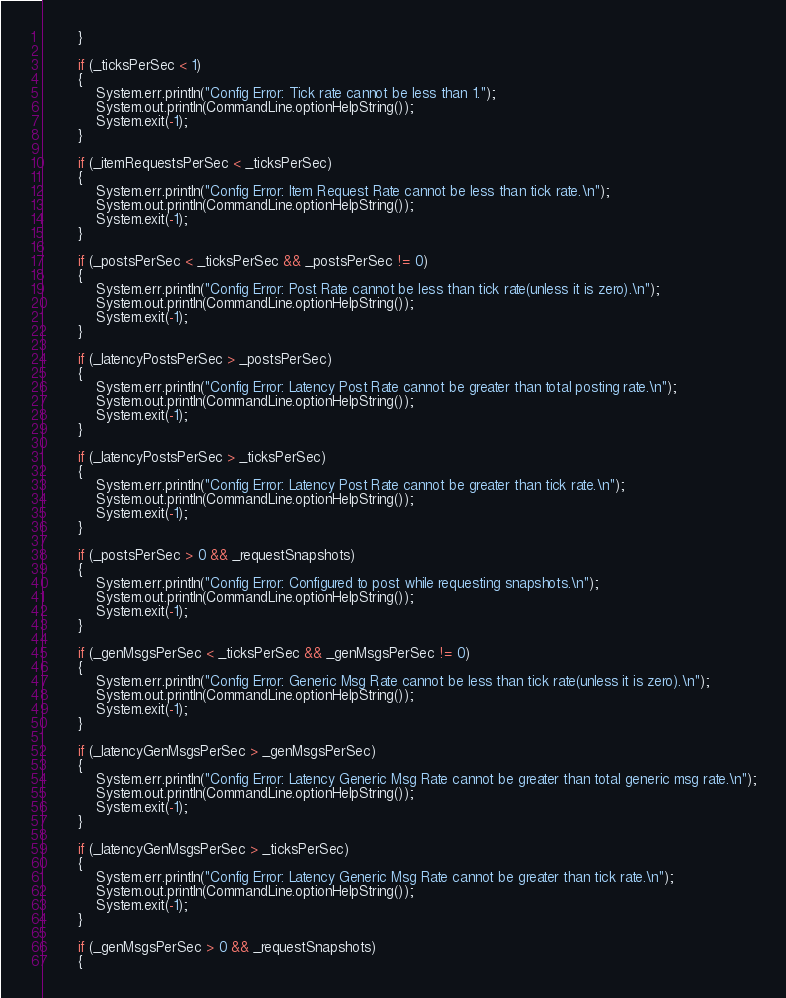<code> <loc_0><loc_0><loc_500><loc_500><_Java_>        }

        if (_ticksPerSec < 1)
        {
            System.err.println("Config Error: Tick rate cannot be less than 1.");
            System.out.println(CommandLine.optionHelpString());
            System.exit(-1);
        } 
        
		if (_itemRequestsPerSec < _ticksPerSec)
		{
			System.err.println("Config Error: Item Request Rate cannot be less than tick rate.\n");
			System.out.println(CommandLine.optionHelpString());
			System.exit(-1);
		}

		if (_postsPerSec < _ticksPerSec && _postsPerSec != 0)
		{
			System.err.println("Config Error: Post Rate cannot be less than tick rate(unless it is zero).\n");
			System.out.println(CommandLine.optionHelpString());
			System.exit(-1);
		}

		if (_latencyPostsPerSec > _postsPerSec)
		{
			System.err.println("Config Error: Latency Post Rate cannot be greater than total posting rate.\n");
			System.out.println(CommandLine.optionHelpString());
			System.exit(-1);
		}

		if (_latencyPostsPerSec > _ticksPerSec)
		{
			System.err.println("Config Error: Latency Post Rate cannot be greater than tick rate.\n");
			System.out.println(CommandLine.optionHelpString());
			System.exit(-1);
		}

		if (_postsPerSec > 0 && _requestSnapshots)
		{
			System.err.println("Config Error: Configured to post while requesting snapshots.\n");
			System.out.println(CommandLine.optionHelpString());
			System.exit(-1);
		}

		if (_genMsgsPerSec < _ticksPerSec && _genMsgsPerSec != 0)
		{
			System.err.println("Config Error: Generic Msg Rate cannot be less than tick rate(unless it is zero).\n");
			System.out.println(CommandLine.optionHelpString());
			System.exit(-1);
		}

		if (_latencyGenMsgsPerSec > _genMsgsPerSec)
		{
			System.err.println("Config Error: Latency Generic Msg Rate cannot be greater than total generic msg rate.\n");
			System.out.println(CommandLine.optionHelpString());
			System.exit(-1);
		}

		if (_latencyGenMsgsPerSec > _ticksPerSec)
		{
			System.err.println("Config Error: Latency Generic Msg Rate cannot be greater than tick rate.\n");
			System.out.println(CommandLine.optionHelpString());
			System.exit(-1);
		}

		if (_genMsgsPerSec > 0 && _requestSnapshots)
		{</code> 